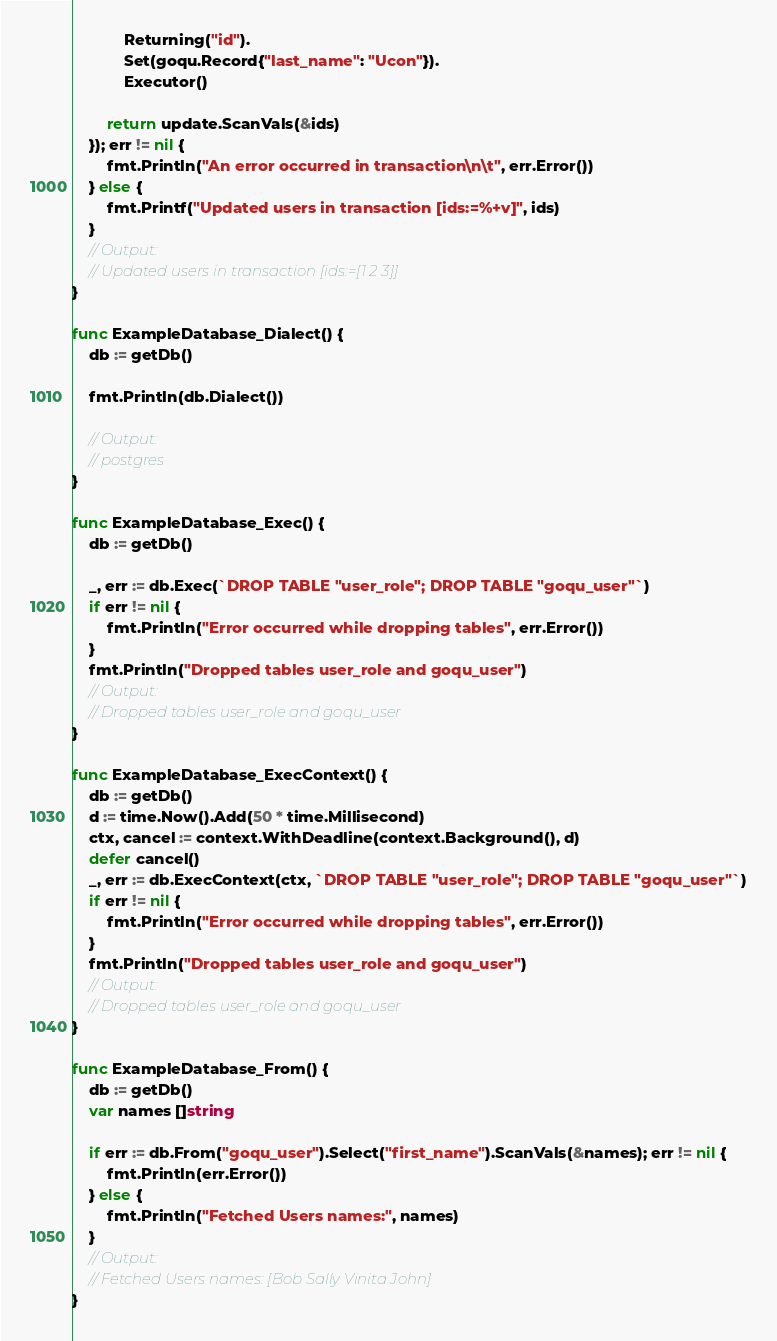<code> <loc_0><loc_0><loc_500><loc_500><_Go_>			Returning("id").
			Set(goqu.Record{"last_name": "Ucon"}).
			Executor()

		return update.ScanVals(&ids)
	}); err != nil {
		fmt.Println("An error occurred in transaction\n\t", err.Error())
	} else {
		fmt.Printf("Updated users in transaction [ids:=%+v]", ids)
	}
	// Output:
	// Updated users in transaction [ids:=[1 2 3]]
}

func ExampleDatabase_Dialect() {
	db := getDb()

	fmt.Println(db.Dialect())

	// Output:
	// postgres
}

func ExampleDatabase_Exec() {
	db := getDb()

	_, err := db.Exec(`DROP TABLE "user_role"; DROP TABLE "goqu_user"`)
	if err != nil {
		fmt.Println("Error occurred while dropping tables", err.Error())
	}
	fmt.Println("Dropped tables user_role and goqu_user")
	// Output:
	// Dropped tables user_role and goqu_user
}

func ExampleDatabase_ExecContext() {
	db := getDb()
	d := time.Now().Add(50 * time.Millisecond)
	ctx, cancel := context.WithDeadline(context.Background(), d)
	defer cancel()
	_, err := db.ExecContext(ctx, `DROP TABLE "user_role"; DROP TABLE "goqu_user"`)
	if err != nil {
		fmt.Println("Error occurred while dropping tables", err.Error())
	}
	fmt.Println("Dropped tables user_role and goqu_user")
	// Output:
	// Dropped tables user_role and goqu_user
}

func ExampleDatabase_From() {
	db := getDb()
	var names []string

	if err := db.From("goqu_user").Select("first_name").ScanVals(&names); err != nil {
		fmt.Println(err.Error())
	} else {
		fmt.Println("Fetched Users names:", names)
	}
	// Output:
	// Fetched Users names: [Bob Sally Vinita John]
}
</code> 